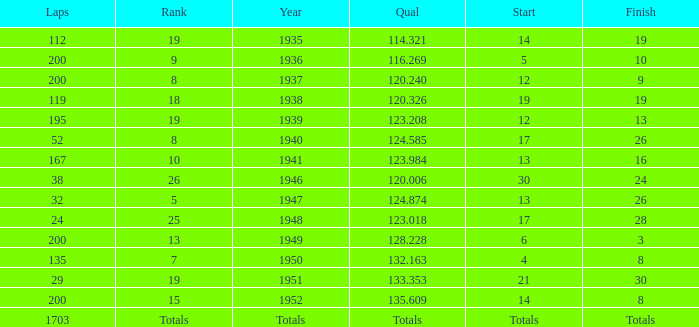With a Rank of 19, and a Start of 14, what was the finish? 19.0. 